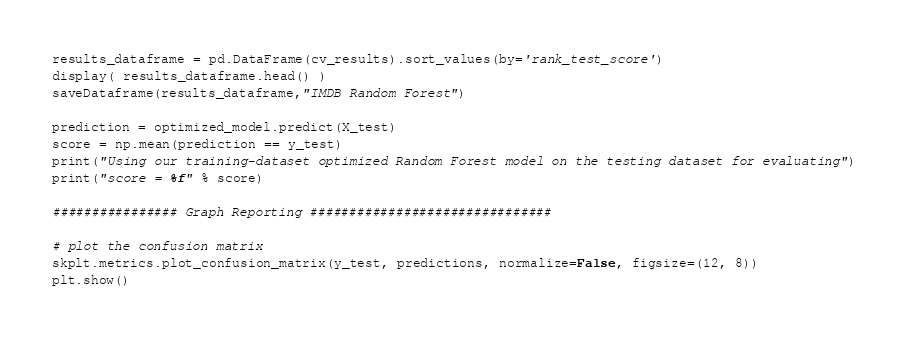<code> <loc_0><loc_0><loc_500><loc_500><_Python_>results_dataframe = pd.DataFrame(cv_results).sort_values(by='rank_test_score')
display( results_dataframe.head() )
saveDataframe(results_dataframe,"IMDB Random Forest")

prediction = optimized_model.predict(X_test)
score = np.mean(prediction == y_test)
print("Using our training-dataset optimized Random Forest model on the testing dataset for evaluating")
print("score = %f" % score)

################ Graph Reporting ###############################

# plot the confusion matrix
skplt.metrics.plot_confusion_matrix(y_test, predictions, normalize=False, figsize=(12, 8))
plt.show()</code> 